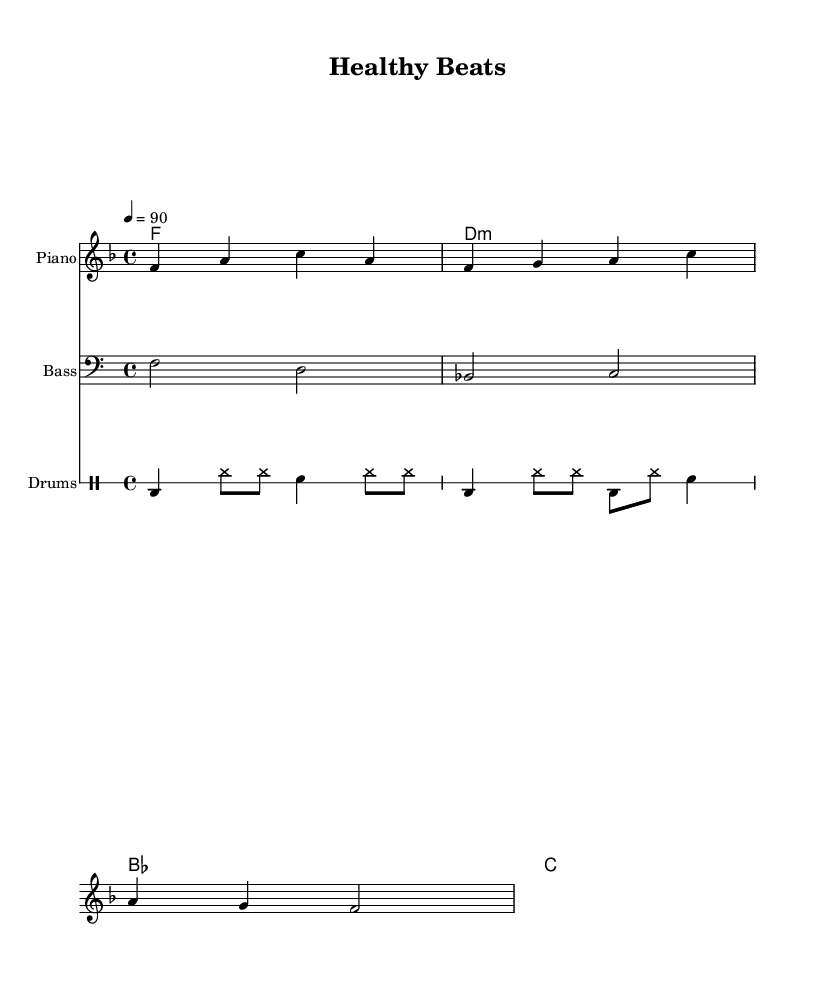What is the key signature of this music? The key signature is F major, which has one flat (B flat). This can be seen at the beginning of the staff where the key signature is indicated.
Answer: F major What is the time signature of this music? The time signature is 4/4, which means there are four beats in a measure and the quarter note gets one beat. This is shown at the beginning of the staff next to the key signature.
Answer: 4/4 What is the tempo marking for this piece? The tempo marking is 90 beats per minute, indicated at the beginning of the score within the global block. This marking directs the performer on how fast to play the piece.
Answer: 90 How many measures are in the melody? The melody consists of three measures, which can be identified by counting the bars in the melody staff. Each bar represents one measure.
Answer: 3 What is the primary message of the lyrics? The primary message of the lyrics is to encourage eating healthy, specifically greens and staying active. The lyrics provided directly express this message.
Answer: Eat your greens, stay in motion What instruments are included in the score? The score includes piano, bass, and drums. This can be determined by looking at the labeled staffs; each instrument has its part visibly notated.
Answer: Piano, bass, drums Which chord starts the piece? The piece starts with the F major chord, indicated in the chord names section at the beginning of the score. This chord establishes the tonal center for the music.
Answer: F 